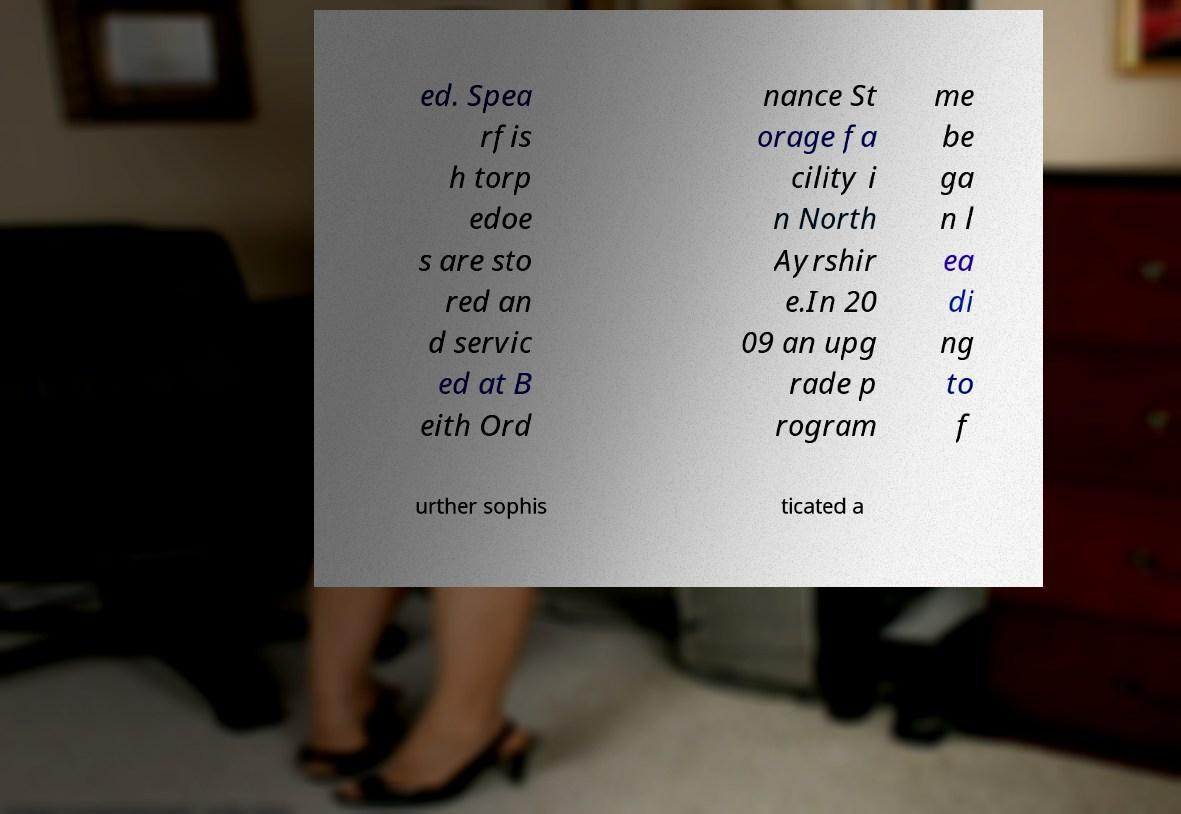Can you read and provide the text displayed in the image?This photo seems to have some interesting text. Can you extract and type it out for me? ed. Spea rfis h torp edoe s are sto red an d servic ed at B eith Ord nance St orage fa cility i n North Ayrshir e.In 20 09 an upg rade p rogram me be ga n l ea di ng to f urther sophis ticated a 